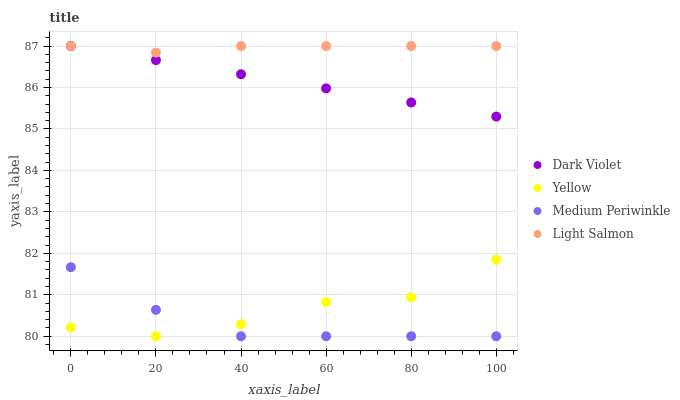Does Medium Periwinkle have the minimum area under the curve?
Answer yes or no. Yes. Does Light Salmon have the maximum area under the curve?
Answer yes or no. Yes. Does Yellow have the minimum area under the curve?
Answer yes or no. No. Does Yellow have the maximum area under the curve?
Answer yes or no. No. Is Dark Violet the smoothest?
Answer yes or no. Yes. Is Yellow the roughest?
Answer yes or no. Yes. Is Medium Periwinkle the smoothest?
Answer yes or no. No. Is Medium Periwinkle the roughest?
Answer yes or no. No. Does Medium Periwinkle have the lowest value?
Answer yes or no. Yes. Does Dark Violet have the lowest value?
Answer yes or no. No. Does Dark Violet have the highest value?
Answer yes or no. Yes. Does Yellow have the highest value?
Answer yes or no. No. Is Yellow less than Light Salmon?
Answer yes or no. Yes. Is Dark Violet greater than Medium Periwinkle?
Answer yes or no. Yes. Does Yellow intersect Medium Periwinkle?
Answer yes or no. Yes. Is Yellow less than Medium Periwinkle?
Answer yes or no. No. Is Yellow greater than Medium Periwinkle?
Answer yes or no. No. Does Yellow intersect Light Salmon?
Answer yes or no. No. 